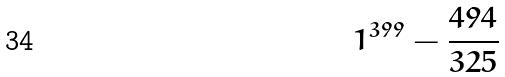Convert formula to latex. <formula><loc_0><loc_0><loc_500><loc_500>1 ^ { 3 9 9 } - \frac { 4 9 4 } { 3 2 5 }</formula> 